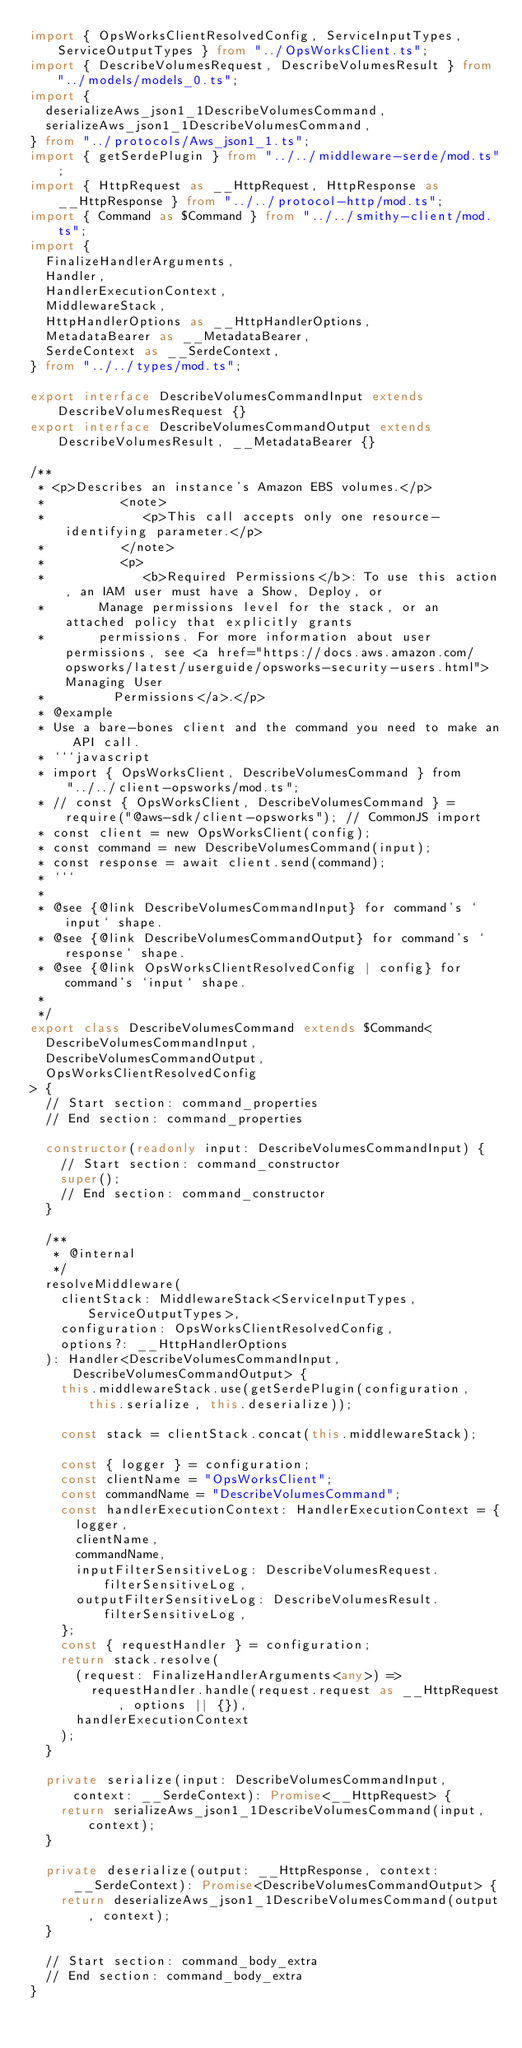<code> <loc_0><loc_0><loc_500><loc_500><_TypeScript_>import { OpsWorksClientResolvedConfig, ServiceInputTypes, ServiceOutputTypes } from "../OpsWorksClient.ts";
import { DescribeVolumesRequest, DescribeVolumesResult } from "../models/models_0.ts";
import {
  deserializeAws_json1_1DescribeVolumesCommand,
  serializeAws_json1_1DescribeVolumesCommand,
} from "../protocols/Aws_json1_1.ts";
import { getSerdePlugin } from "../../middleware-serde/mod.ts";
import { HttpRequest as __HttpRequest, HttpResponse as __HttpResponse } from "../../protocol-http/mod.ts";
import { Command as $Command } from "../../smithy-client/mod.ts";
import {
  FinalizeHandlerArguments,
  Handler,
  HandlerExecutionContext,
  MiddlewareStack,
  HttpHandlerOptions as __HttpHandlerOptions,
  MetadataBearer as __MetadataBearer,
  SerdeContext as __SerdeContext,
} from "../../types/mod.ts";

export interface DescribeVolumesCommandInput extends DescribeVolumesRequest {}
export interface DescribeVolumesCommandOutput extends DescribeVolumesResult, __MetadataBearer {}

/**
 * <p>Describes an instance's Amazon EBS volumes.</p>
 *          <note>
 *             <p>This call accepts only one resource-identifying parameter.</p>
 *          </note>
 *          <p>
 *             <b>Required Permissions</b>: To use this action, an IAM user must have a Show, Deploy, or
 *       Manage permissions level for the stack, or an attached policy that explicitly grants
 *       permissions. For more information about user permissions, see <a href="https://docs.aws.amazon.com/opsworks/latest/userguide/opsworks-security-users.html">Managing User
 *         Permissions</a>.</p>
 * @example
 * Use a bare-bones client and the command you need to make an API call.
 * ```javascript
 * import { OpsWorksClient, DescribeVolumesCommand } from "../../client-opsworks/mod.ts";
 * // const { OpsWorksClient, DescribeVolumesCommand } = require("@aws-sdk/client-opsworks"); // CommonJS import
 * const client = new OpsWorksClient(config);
 * const command = new DescribeVolumesCommand(input);
 * const response = await client.send(command);
 * ```
 *
 * @see {@link DescribeVolumesCommandInput} for command's `input` shape.
 * @see {@link DescribeVolumesCommandOutput} for command's `response` shape.
 * @see {@link OpsWorksClientResolvedConfig | config} for command's `input` shape.
 *
 */
export class DescribeVolumesCommand extends $Command<
  DescribeVolumesCommandInput,
  DescribeVolumesCommandOutput,
  OpsWorksClientResolvedConfig
> {
  // Start section: command_properties
  // End section: command_properties

  constructor(readonly input: DescribeVolumesCommandInput) {
    // Start section: command_constructor
    super();
    // End section: command_constructor
  }

  /**
   * @internal
   */
  resolveMiddleware(
    clientStack: MiddlewareStack<ServiceInputTypes, ServiceOutputTypes>,
    configuration: OpsWorksClientResolvedConfig,
    options?: __HttpHandlerOptions
  ): Handler<DescribeVolumesCommandInput, DescribeVolumesCommandOutput> {
    this.middlewareStack.use(getSerdePlugin(configuration, this.serialize, this.deserialize));

    const stack = clientStack.concat(this.middlewareStack);

    const { logger } = configuration;
    const clientName = "OpsWorksClient";
    const commandName = "DescribeVolumesCommand";
    const handlerExecutionContext: HandlerExecutionContext = {
      logger,
      clientName,
      commandName,
      inputFilterSensitiveLog: DescribeVolumesRequest.filterSensitiveLog,
      outputFilterSensitiveLog: DescribeVolumesResult.filterSensitiveLog,
    };
    const { requestHandler } = configuration;
    return stack.resolve(
      (request: FinalizeHandlerArguments<any>) =>
        requestHandler.handle(request.request as __HttpRequest, options || {}),
      handlerExecutionContext
    );
  }

  private serialize(input: DescribeVolumesCommandInput, context: __SerdeContext): Promise<__HttpRequest> {
    return serializeAws_json1_1DescribeVolumesCommand(input, context);
  }

  private deserialize(output: __HttpResponse, context: __SerdeContext): Promise<DescribeVolumesCommandOutput> {
    return deserializeAws_json1_1DescribeVolumesCommand(output, context);
  }

  // Start section: command_body_extra
  // End section: command_body_extra
}
</code> 